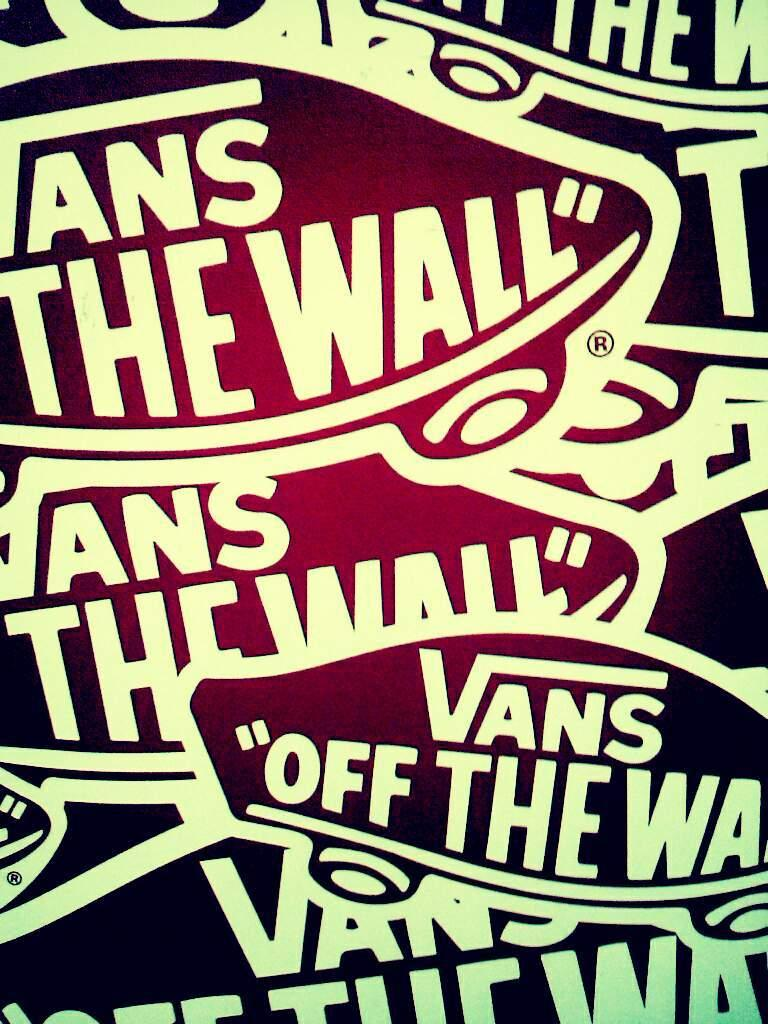<image>
Relay a brief, clear account of the picture shown. Multiple stickers of "Vans Off the Wall" crossing over one another. 